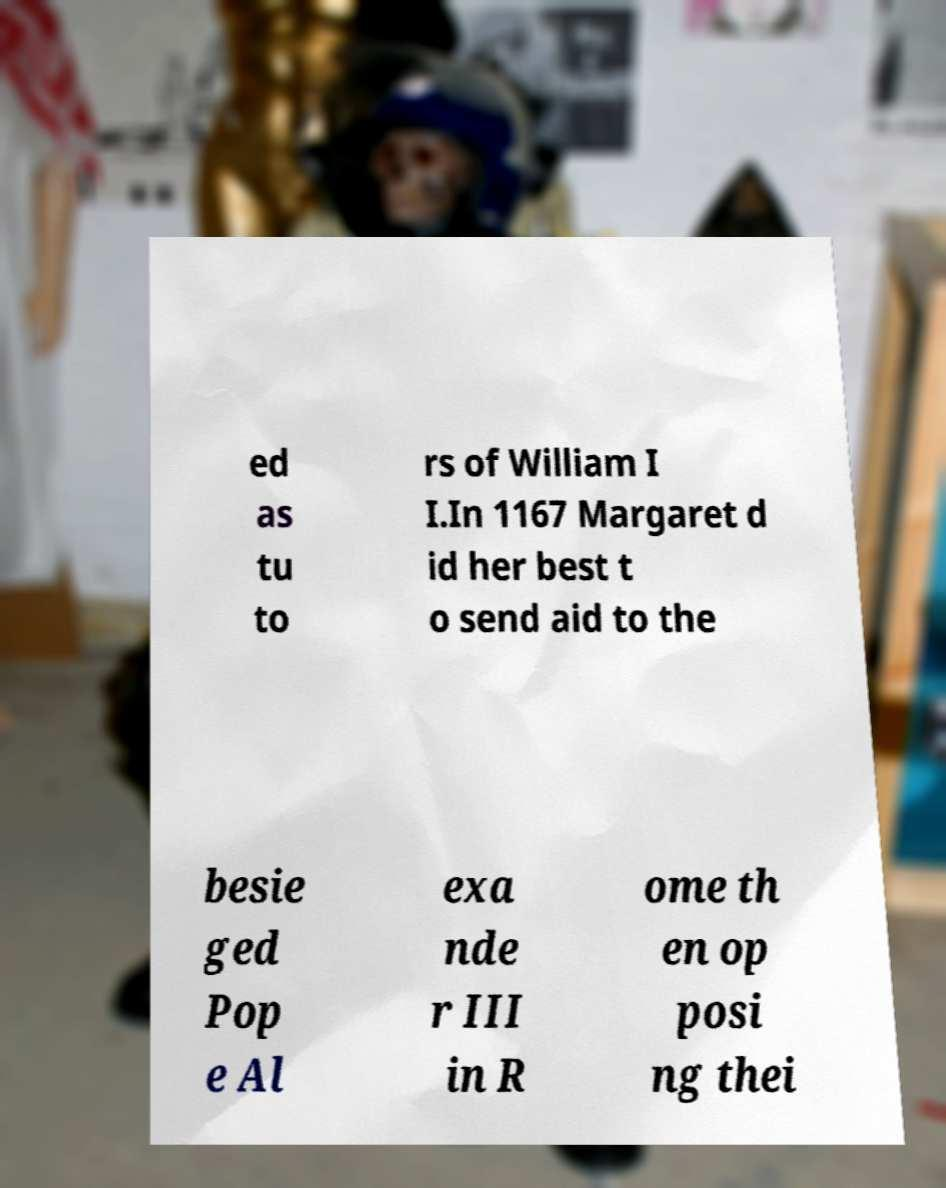Please read and relay the text visible in this image. What does it say? ed as tu to rs of William I I.In 1167 Margaret d id her best t o send aid to the besie ged Pop e Al exa nde r III in R ome th en op posi ng thei 